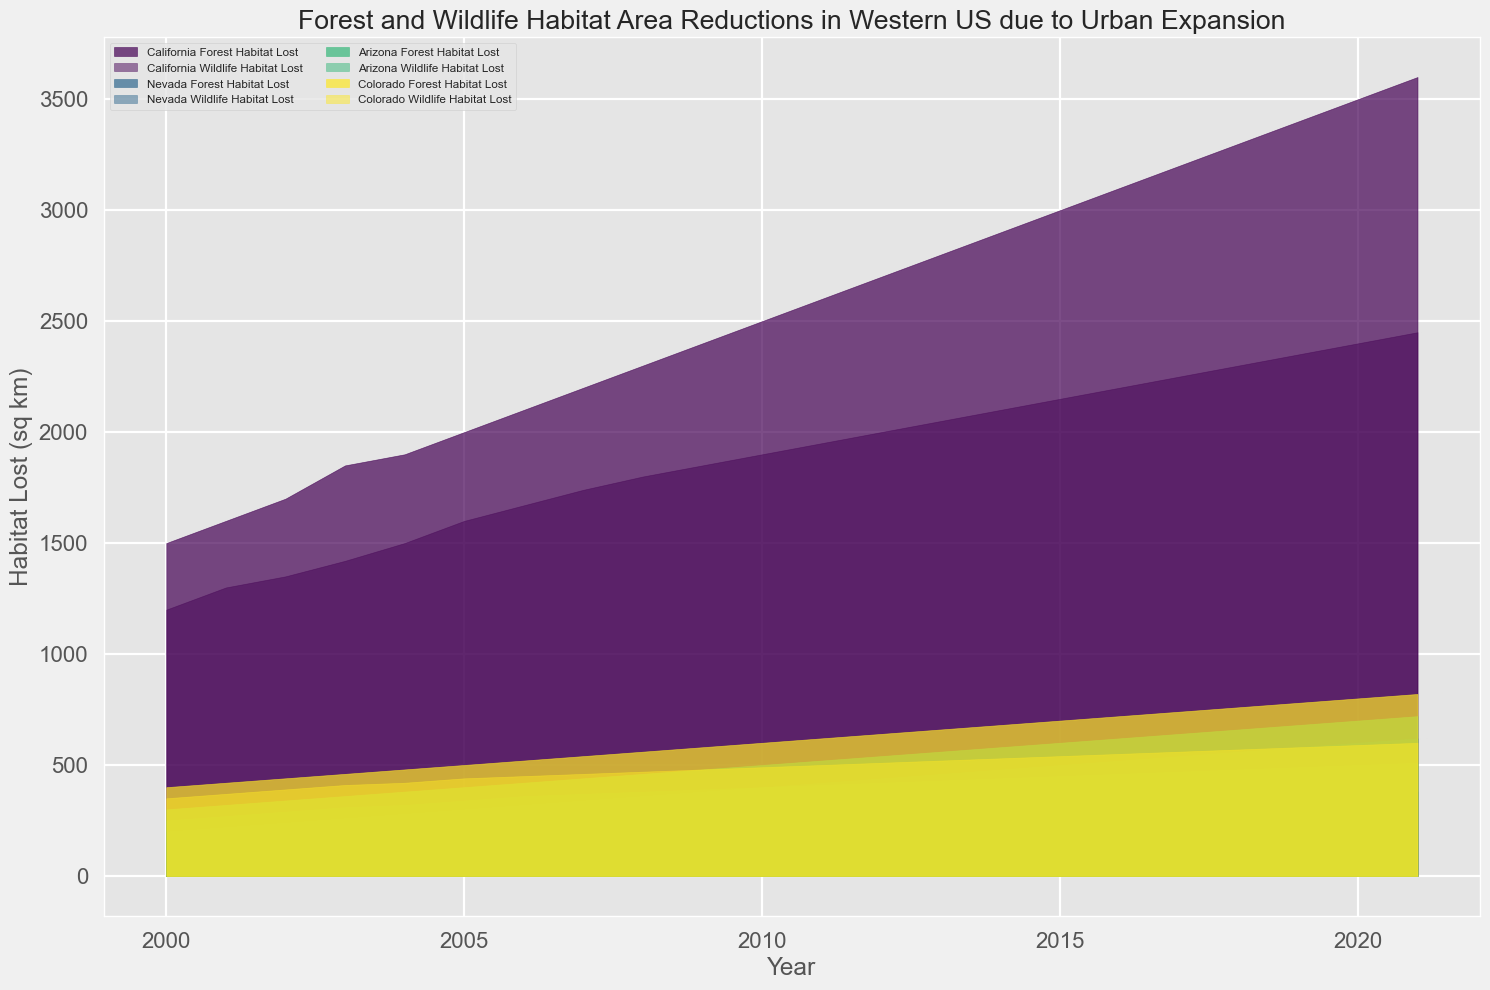Which state had the most forest habitat lost in 2021? Look at the plot for the year 2021 and compare the heights of the areas representing forest habitat loss for each state. California clearly has the tallest area for that year.
Answer: California Which state experienced a greater total habitat loss in 2010, Arizona or Nevada? Check the heights of both the forest and wildlife habitat loss areas for Arizona and Nevada in 2010, and sum the values for each state. Arizona: 500 + 400 = 900; Nevada: 400 + 270 = 670.
Answer: Arizona In which year was the forest habitat lost in Colorado equal to the wildlife habitat lost in Arizona? Observe the plot and look for overlapping areas where the forest habitat loss in Colorado matches the height of the wildlife habitat loss in Arizona. This occurs in 2021, where both values are 600 sq km.
Answer: 2021 How did the forest habitat loss in Nevada change from 2005 to 2010? Look at the heights of the forest habitat loss area for Nevada in 2005 and 2010. Subtract the 2005 value (300 sq km) from the 2010 value (400 sq km). The change is 400 - 300 = 100 sq km.
Answer: Increased by 100 sq km Which year did California experience a forest habitat loss of 3000 sq km? Find the point along the timeline for California where the forest habitat loss area reaches 3000 sq km. This occurs in 2015.
Answer: 2015 What is the difference in wildlife habitat loss between California and Colorado in 2008? Check the heights of the wildlife habitat loss area for California (1800 sq km) and Colorado (470 sq km) in 2008. Subtract Colorado's value from California's: 1800 - 470 = 1330 sq km.
Answer: 1330 sq km Which state had a more gradual increase in forest habitat loss from 2000 to 2021: Arizona or Colorado? Compare the overall slopes formed by the forest habitat loss areas for Arizona and Colorado over the years from 2000 to 2021. Colorado shows a more gradual, steady increase compared to Arizona.
Answer: Colorado By how much did the wildlife habitat loss in Nevada increase from 2000 to 2010? Look at the heights of the wildlife habitat loss area for Nevada in 2000 (150 sq km) and in 2010 (270 sq km). The increase is 270 - 150 = 120 sq km.
Answer: 120 sq km What was the approximate total habitat loss (forest and wildlife) for California in 2020? Add the forest habitat loss (3500 sq km) to the wildlife habitat loss (2400 sq km) for California in 2020. 3500 + 2400 = 5900 sq km.
Answer: 5900 sq km Which state had the smallest overall habitat loss in 2008? Compare the combined heights of the forest and wildlife habitat loss areas for each state in 2008. Nevada shows the smallest combined height: Nevada (360 + 250 = 610 sq km).
Answer: Nevada 